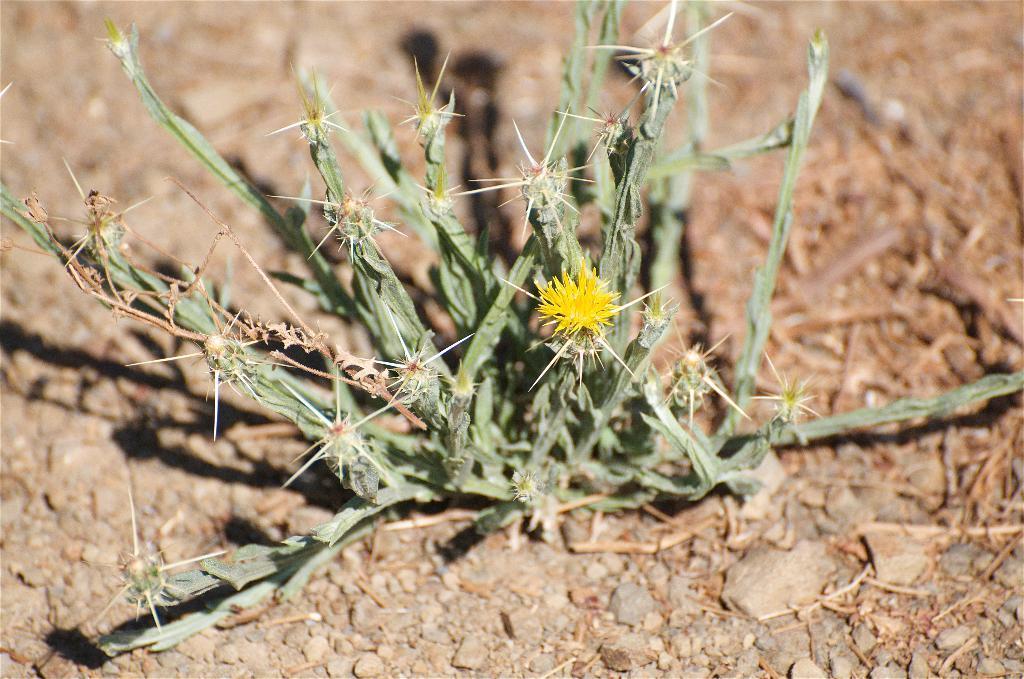Could you give a brief overview of what you see in this image? In this image in the center there is one plant and flowers, at the bottom there are some small stones and dry grass. 